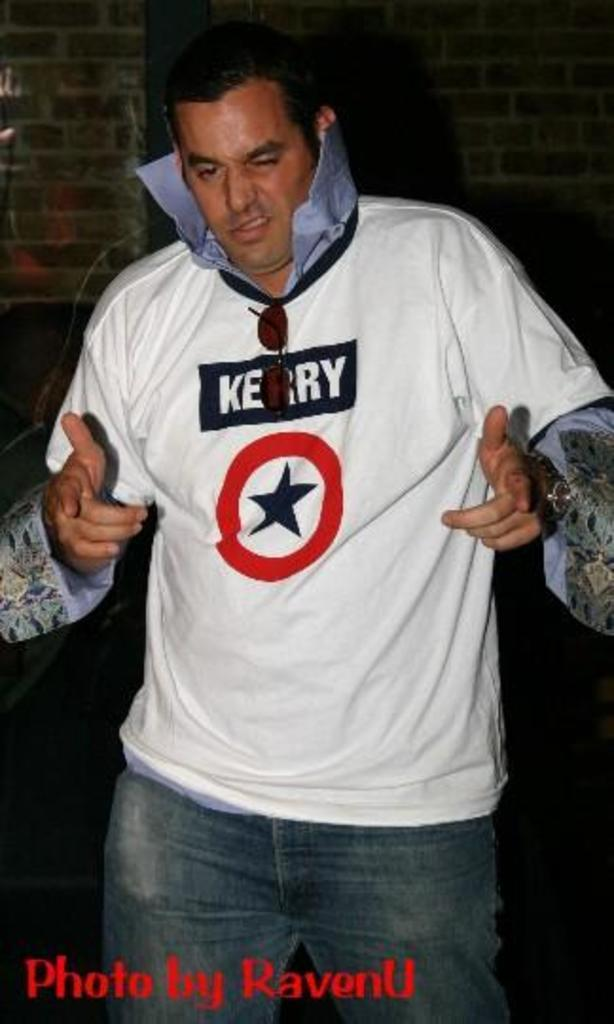<image>
Offer a succinct explanation of the picture presented. A middle aged man is striking an Elvis pose, wearing a white shirt that says Kerry above a black star with a red circle around it. 